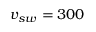Convert formula to latex. <formula><loc_0><loc_0><loc_500><loc_500>v _ { s w } = 3 0 0</formula> 